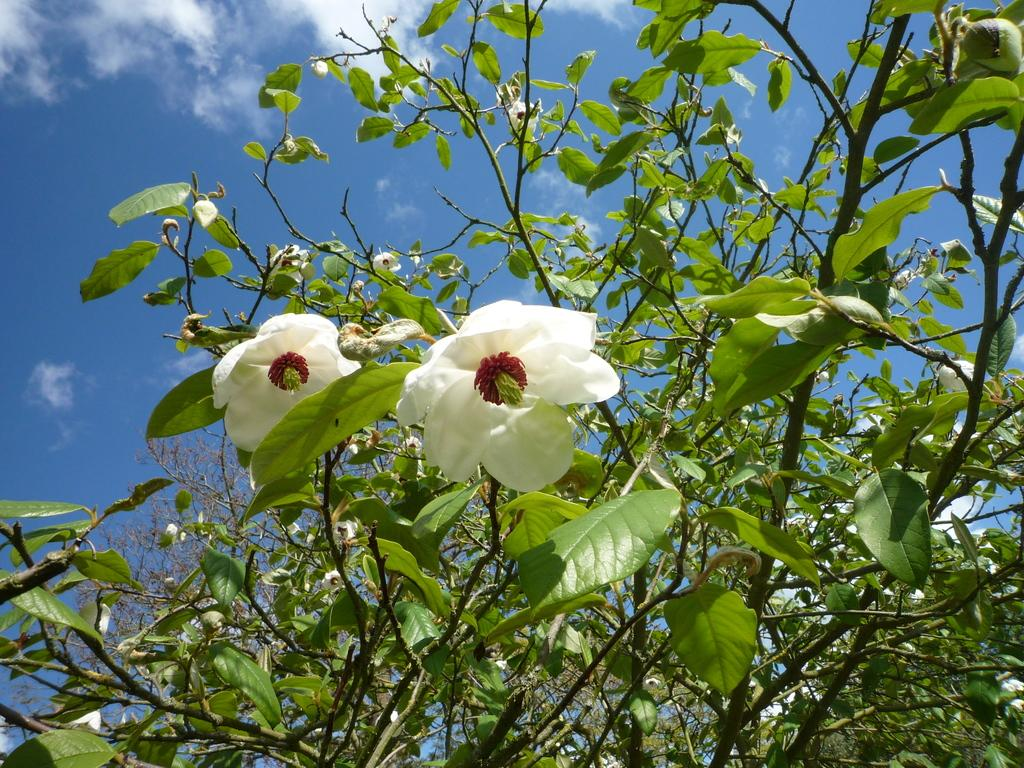What type of vegetation can be seen in the image? There are trees in the image. What is the color of the trees in the image? The trees are green in color. What other natural elements can be seen in the image? There are flowers in the image. What colors are the flowers in the image? The flowers are white, red, and green in color. What is visible in the background of the image? The sky is visible in the background of the image. Can you tell me how many apples are on the lawyer's desk in the image? There is no lawyer or desk present in the image; it features trees, flowers, and the sky. Is there a mailbox visible in the image? There is no mailbox present in the image. 